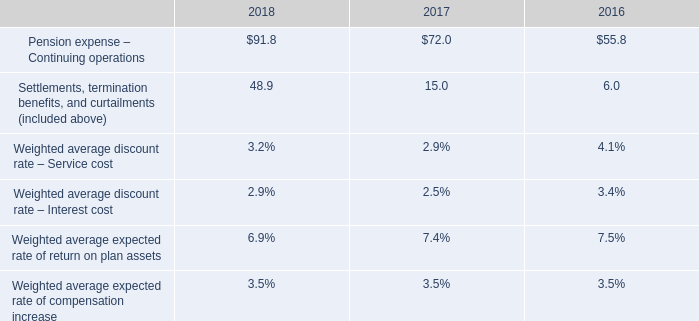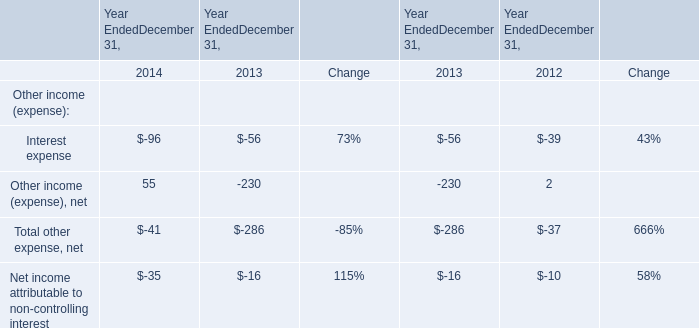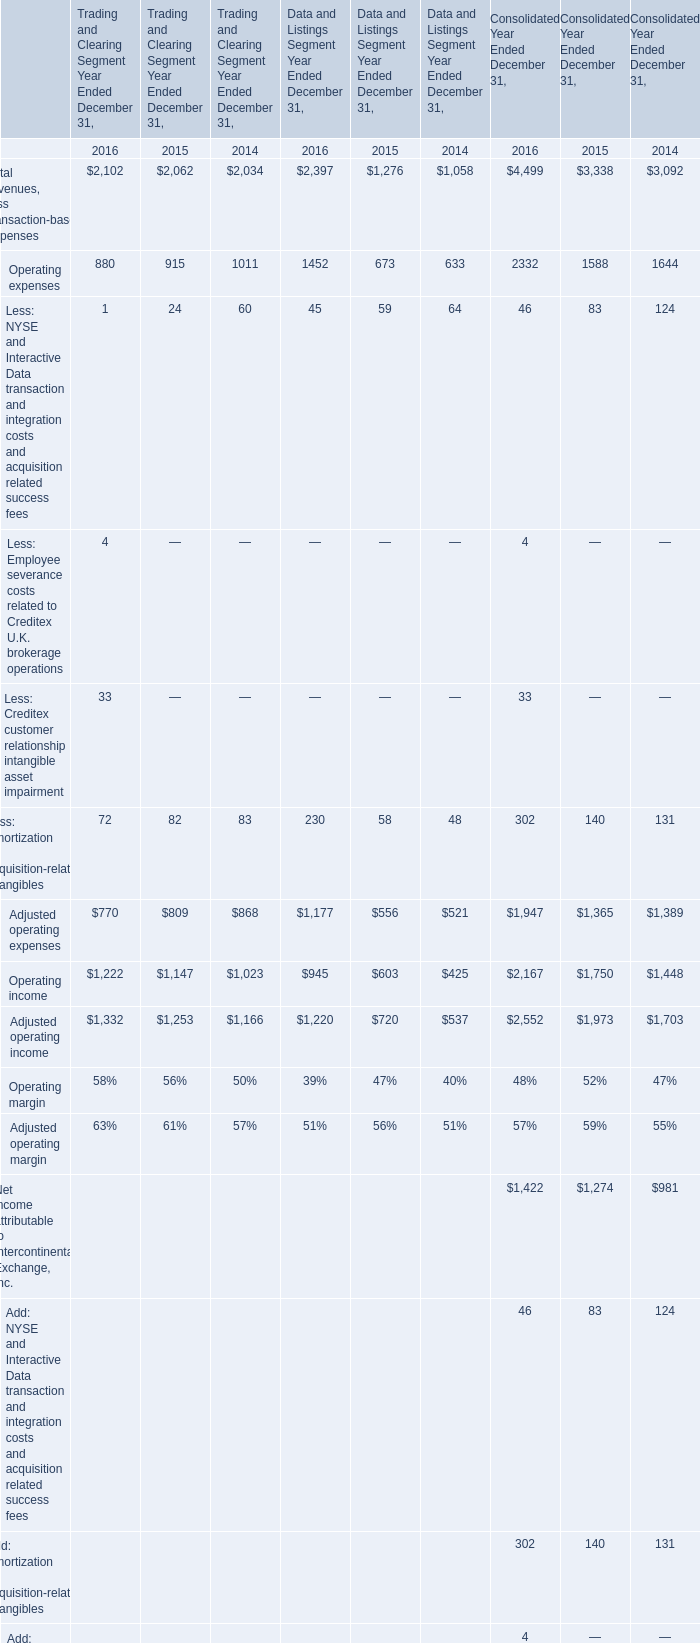What was the average value of Adjusted operating expenses, Operating income, Adjusted operating income for Data and Listings Segment Year Ended December 31 in 2016 ? 
Computations: (((1177 + 945) + 1220) / 3)
Answer: 1114.0. 